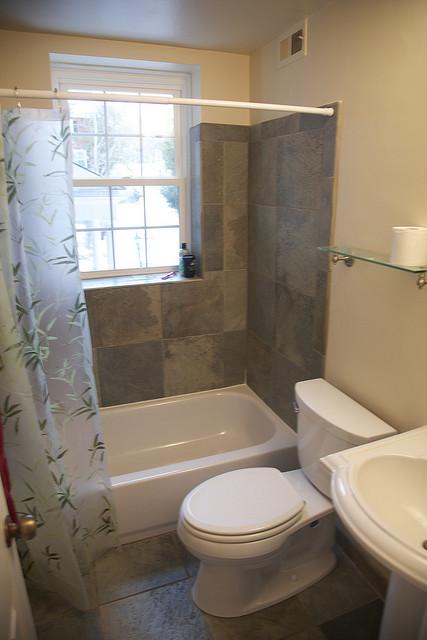What on top of the glass shelf above the toilet?
Answer briefly. Toilet paper. Is the shower curtain open or shut?
Short answer required. Open. What room is this?
Short answer required. Bathroom. What material is the toilet seat made out of?
Quick response, please. Plastic. 